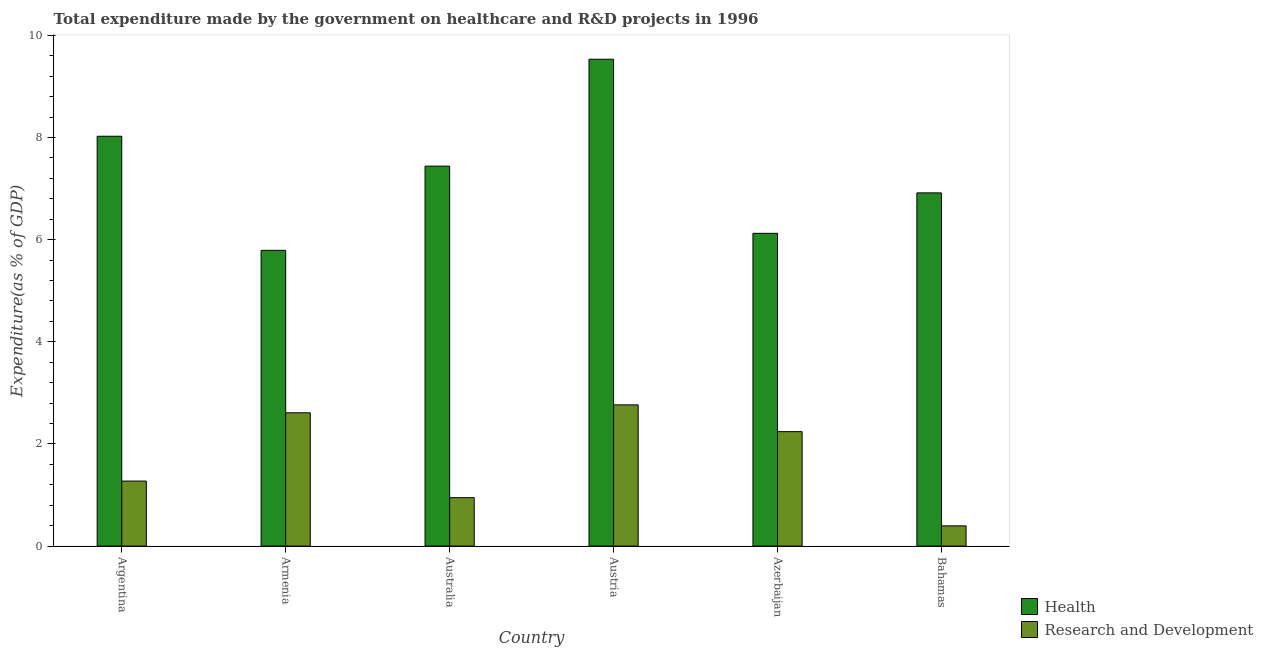How many different coloured bars are there?
Your answer should be very brief. 2. Are the number of bars per tick equal to the number of legend labels?
Provide a short and direct response. Yes. Are the number of bars on each tick of the X-axis equal?
Your answer should be compact. Yes. What is the label of the 2nd group of bars from the left?
Offer a terse response. Armenia. What is the expenditure in r&d in Argentina?
Provide a succinct answer. 1.27. Across all countries, what is the maximum expenditure in healthcare?
Give a very brief answer. 9.53. Across all countries, what is the minimum expenditure in healthcare?
Provide a succinct answer. 5.79. In which country was the expenditure in r&d minimum?
Give a very brief answer. Bahamas. What is the total expenditure in healthcare in the graph?
Provide a succinct answer. 43.83. What is the difference between the expenditure in r&d in Austria and that in Azerbaijan?
Give a very brief answer. 0.52. What is the difference between the expenditure in r&d in Bahamas and the expenditure in healthcare in Azerbaijan?
Keep it short and to the point. -5.73. What is the average expenditure in healthcare per country?
Make the answer very short. 7.3. What is the difference between the expenditure in r&d and expenditure in healthcare in Azerbaijan?
Give a very brief answer. -3.88. In how many countries, is the expenditure in healthcare greater than 8 %?
Your answer should be compact. 2. What is the ratio of the expenditure in r&d in Argentina to that in Azerbaijan?
Provide a succinct answer. 0.57. Is the expenditure in r&d in Argentina less than that in Austria?
Give a very brief answer. Yes. Is the difference between the expenditure in r&d in Armenia and Azerbaijan greater than the difference between the expenditure in healthcare in Armenia and Azerbaijan?
Provide a short and direct response. Yes. What is the difference between the highest and the second highest expenditure in healthcare?
Give a very brief answer. 1.51. What is the difference between the highest and the lowest expenditure in r&d?
Keep it short and to the point. 2.37. Is the sum of the expenditure in healthcare in Argentina and Armenia greater than the maximum expenditure in r&d across all countries?
Your answer should be compact. Yes. What does the 2nd bar from the left in Bahamas represents?
Keep it short and to the point. Research and Development. What does the 2nd bar from the right in Australia represents?
Give a very brief answer. Health. How many bars are there?
Your answer should be compact. 12. How many countries are there in the graph?
Make the answer very short. 6. What is the difference between two consecutive major ticks on the Y-axis?
Ensure brevity in your answer.  2. Are the values on the major ticks of Y-axis written in scientific E-notation?
Your answer should be very brief. No. Where does the legend appear in the graph?
Give a very brief answer. Bottom right. What is the title of the graph?
Your answer should be compact. Total expenditure made by the government on healthcare and R&D projects in 1996. Does "Technicians" appear as one of the legend labels in the graph?
Give a very brief answer. No. What is the label or title of the X-axis?
Your answer should be compact. Country. What is the label or title of the Y-axis?
Ensure brevity in your answer.  Expenditure(as % of GDP). What is the Expenditure(as % of GDP) in Health in Argentina?
Keep it short and to the point. 8.02. What is the Expenditure(as % of GDP) in Research and Development in Argentina?
Give a very brief answer. 1.27. What is the Expenditure(as % of GDP) of Health in Armenia?
Offer a terse response. 5.79. What is the Expenditure(as % of GDP) in Research and Development in Armenia?
Your response must be concise. 2.61. What is the Expenditure(as % of GDP) of Health in Australia?
Keep it short and to the point. 7.44. What is the Expenditure(as % of GDP) in Research and Development in Australia?
Offer a very short reply. 0.95. What is the Expenditure(as % of GDP) in Health in Austria?
Ensure brevity in your answer.  9.53. What is the Expenditure(as % of GDP) in Research and Development in Austria?
Your answer should be very brief. 2.77. What is the Expenditure(as % of GDP) of Health in Azerbaijan?
Make the answer very short. 6.12. What is the Expenditure(as % of GDP) of Research and Development in Azerbaijan?
Your answer should be very brief. 2.24. What is the Expenditure(as % of GDP) in Health in Bahamas?
Your answer should be very brief. 6.92. What is the Expenditure(as % of GDP) of Research and Development in Bahamas?
Keep it short and to the point. 0.4. Across all countries, what is the maximum Expenditure(as % of GDP) of Health?
Your answer should be very brief. 9.53. Across all countries, what is the maximum Expenditure(as % of GDP) in Research and Development?
Make the answer very short. 2.77. Across all countries, what is the minimum Expenditure(as % of GDP) in Health?
Provide a short and direct response. 5.79. Across all countries, what is the minimum Expenditure(as % of GDP) of Research and Development?
Give a very brief answer. 0.4. What is the total Expenditure(as % of GDP) in Health in the graph?
Your response must be concise. 43.83. What is the total Expenditure(as % of GDP) of Research and Development in the graph?
Your answer should be very brief. 10.23. What is the difference between the Expenditure(as % of GDP) of Health in Argentina and that in Armenia?
Offer a very short reply. 2.23. What is the difference between the Expenditure(as % of GDP) in Research and Development in Argentina and that in Armenia?
Provide a succinct answer. -1.34. What is the difference between the Expenditure(as % of GDP) in Health in Argentina and that in Australia?
Give a very brief answer. 0.59. What is the difference between the Expenditure(as % of GDP) in Research and Development in Argentina and that in Australia?
Give a very brief answer. 0.33. What is the difference between the Expenditure(as % of GDP) in Health in Argentina and that in Austria?
Offer a terse response. -1.51. What is the difference between the Expenditure(as % of GDP) in Research and Development in Argentina and that in Austria?
Provide a short and direct response. -1.49. What is the difference between the Expenditure(as % of GDP) of Health in Argentina and that in Azerbaijan?
Make the answer very short. 1.9. What is the difference between the Expenditure(as % of GDP) of Research and Development in Argentina and that in Azerbaijan?
Your answer should be compact. -0.97. What is the difference between the Expenditure(as % of GDP) of Health in Argentina and that in Bahamas?
Make the answer very short. 1.11. What is the difference between the Expenditure(as % of GDP) in Research and Development in Argentina and that in Bahamas?
Keep it short and to the point. 0.88. What is the difference between the Expenditure(as % of GDP) of Health in Armenia and that in Australia?
Provide a succinct answer. -1.65. What is the difference between the Expenditure(as % of GDP) of Research and Development in Armenia and that in Australia?
Offer a terse response. 1.66. What is the difference between the Expenditure(as % of GDP) of Health in Armenia and that in Austria?
Your answer should be compact. -3.74. What is the difference between the Expenditure(as % of GDP) of Research and Development in Armenia and that in Austria?
Offer a terse response. -0.15. What is the difference between the Expenditure(as % of GDP) in Health in Armenia and that in Azerbaijan?
Provide a succinct answer. -0.33. What is the difference between the Expenditure(as % of GDP) of Research and Development in Armenia and that in Azerbaijan?
Offer a terse response. 0.37. What is the difference between the Expenditure(as % of GDP) of Health in Armenia and that in Bahamas?
Provide a succinct answer. -1.13. What is the difference between the Expenditure(as % of GDP) of Research and Development in Armenia and that in Bahamas?
Give a very brief answer. 2.21. What is the difference between the Expenditure(as % of GDP) of Health in Australia and that in Austria?
Ensure brevity in your answer.  -2.09. What is the difference between the Expenditure(as % of GDP) in Research and Development in Australia and that in Austria?
Give a very brief answer. -1.82. What is the difference between the Expenditure(as % of GDP) in Health in Australia and that in Azerbaijan?
Offer a very short reply. 1.32. What is the difference between the Expenditure(as % of GDP) of Research and Development in Australia and that in Azerbaijan?
Provide a succinct answer. -1.29. What is the difference between the Expenditure(as % of GDP) of Health in Australia and that in Bahamas?
Keep it short and to the point. 0.52. What is the difference between the Expenditure(as % of GDP) in Research and Development in Australia and that in Bahamas?
Keep it short and to the point. 0.55. What is the difference between the Expenditure(as % of GDP) of Health in Austria and that in Azerbaijan?
Your answer should be very brief. 3.41. What is the difference between the Expenditure(as % of GDP) of Research and Development in Austria and that in Azerbaijan?
Give a very brief answer. 0.52. What is the difference between the Expenditure(as % of GDP) of Health in Austria and that in Bahamas?
Provide a succinct answer. 2.62. What is the difference between the Expenditure(as % of GDP) in Research and Development in Austria and that in Bahamas?
Provide a short and direct response. 2.37. What is the difference between the Expenditure(as % of GDP) of Health in Azerbaijan and that in Bahamas?
Provide a succinct answer. -0.79. What is the difference between the Expenditure(as % of GDP) in Research and Development in Azerbaijan and that in Bahamas?
Provide a short and direct response. 1.84. What is the difference between the Expenditure(as % of GDP) of Health in Argentina and the Expenditure(as % of GDP) of Research and Development in Armenia?
Your answer should be compact. 5.41. What is the difference between the Expenditure(as % of GDP) in Health in Argentina and the Expenditure(as % of GDP) in Research and Development in Australia?
Provide a succinct answer. 7.08. What is the difference between the Expenditure(as % of GDP) in Health in Argentina and the Expenditure(as % of GDP) in Research and Development in Austria?
Your answer should be very brief. 5.26. What is the difference between the Expenditure(as % of GDP) in Health in Argentina and the Expenditure(as % of GDP) in Research and Development in Azerbaijan?
Ensure brevity in your answer.  5.78. What is the difference between the Expenditure(as % of GDP) in Health in Argentina and the Expenditure(as % of GDP) in Research and Development in Bahamas?
Offer a terse response. 7.63. What is the difference between the Expenditure(as % of GDP) in Health in Armenia and the Expenditure(as % of GDP) in Research and Development in Australia?
Give a very brief answer. 4.84. What is the difference between the Expenditure(as % of GDP) in Health in Armenia and the Expenditure(as % of GDP) in Research and Development in Austria?
Make the answer very short. 3.03. What is the difference between the Expenditure(as % of GDP) of Health in Armenia and the Expenditure(as % of GDP) of Research and Development in Azerbaijan?
Your answer should be compact. 3.55. What is the difference between the Expenditure(as % of GDP) in Health in Armenia and the Expenditure(as % of GDP) in Research and Development in Bahamas?
Give a very brief answer. 5.39. What is the difference between the Expenditure(as % of GDP) in Health in Australia and the Expenditure(as % of GDP) in Research and Development in Austria?
Give a very brief answer. 4.67. What is the difference between the Expenditure(as % of GDP) in Health in Australia and the Expenditure(as % of GDP) in Research and Development in Azerbaijan?
Give a very brief answer. 5.2. What is the difference between the Expenditure(as % of GDP) of Health in Australia and the Expenditure(as % of GDP) of Research and Development in Bahamas?
Ensure brevity in your answer.  7.04. What is the difference between the Expenditure(as % of GDP) in Health in Austria and the Expenditure(as % of GDP) in Research and Development in Azerbaijan?
Offer a terse response. 7.29. What is the difference between the Expenditure(as % of GDP) of Health in Austria and the Expenditure(as % of GDP) of Research and Development in Bahamas?
Offer a terse response. 9.14. What is the difference between the Expenditure(as % of GDP) in Health in Azerbaijan and the Expenditure(as % of GDP) in Research and Development in Bahamas?
Offer a very short reply. 5.73. What is the average Expenditure(as % of GDP) in Health per country?
Keep it short and to the point. 7.3. What is the average Expenditure(as % of GDP) in Research and Development per country?
Your answer should be compact. 1.71. What is the difference between the Expenditure(as % of GDP) in Health and Expenditure(as % of GDP) in Research and Development in Argentina?
Keep it short and to the point. 6.75. What is the difference between the Expenditure(as % of GDP) of Health and Expenditure(as % of GDP) of Research and Development in Armenia?
Provide a succinct answer. 3.18. What is the difference between the Expenditure(as % of GDP) in Health and Expenditure(as % of GDP) in Research and Development in Australia?
Keep it short and to the point. 6.49. What is the difference between the Expenditure(as % of GDP) in Health and Expenditure(as % of GDP) in Research and Development in Austria?
Provide a succinct answer. 6.77. What is the difference between the Expenditure(as % of GDP) of Health and Expenditure(as % of GDP) of Research and Development in Azerbaijan?
Provide a succinct answer. 3.88. What is the difference between the Expenditure(as % of GDP) in Health and Expenditure(as % of GDP) in Research and Development in Bahamas?
Ensure brevity in your answer.  6.52. What is the ratio of the Expenditure(as % of GDP) in Health in Argentina to that in Armenia?
Offer a terse response. 1.39. What is the ratio of the Expenditure(as % of GDP) of Research and Development in Argentina to that in Armenia?
Offer a terse response. 0.49. What is the ratio of the Expenditure(as % of GDP) of Health in Argentina to that in Australia?
Ensure brevity in your answer.  1.08. What is the ratio of the Expenditure(as % of GDP) in Research and Development in Argentina to that in Australia?
Keep it short and to the point. 1.34. What is the ratio of the Expenditure(as % of GDP) in Health in Argentina to that in Austria?
Make the answer very short. 0.84. What is the ratio of the Expenditure(as % of GDP) of Research and Development in Argentina to that in Austria?
Provide a succinct answer. 0.46. What is the ratio of the Expenditure(as % of GDP) in Health in Argentina to that in Azerbaijan?
Offer a terse response. 1.31. What is the ratio of the Expenditure(as % of GDP) in Research and Development in Argentina to that in Azerbaijan?
Your answer should be compact. 0.57. What is the ratio of the Expenditure(as % of GDP) of Health in Argentina to that in Bahamas?
Your response must be concise. 1.16. What is the ratio of the Expenditure(as % of GDP) in Research and Development in Argentina to that in Bahamas?
Keep it short and to the point. 3.21. What is the ratio of the Expenditure(as % of GDP) in Health in Armenia to that in Australia?
Provide a short and direct response. 0.78. What is the ratio of the Expenditure(as % of GDP) in Research and Development in Armenia to that in Australia?
Give a very brief answer. 2.75. What is the ratio of the Expenditure(as % of GDP) of Health in Armenia to that in Austria?
Keep it short and to the point. 0.61. What is the ratio of the Expenditure(as % of GDP) in Research and Development in Armenia to that in Austria?
Make the answer very short. 0.94. What is the ratio of the Expenditure(as % of GDP) in Health in Armenia to that in Azerbaijan?
Your response must be concise. 0.95. What is the ratio of the Expenditure(as % of GDP) in Research and Development in Armenia to that in Azerbaijan?
Your response must be concise. 1.16. What is the ratio of the Expenditure(as % of GDP) of Health in Armenia to that in Bahamas?
Provide a short and direct response. 0.84. What is the ratio of the Expenditure(as % of GDP) of Research and Development in Armenia to that in Bahamas?
Ensure brevity in your answer.  6.59. What is the ratio of the Expenditure(as % of GDP) in Health in Australia to that in Austria?
Provide a short and direct response. 0.78. What is the ratio of the Expenditure(as % of GDP) in Research and Development in Australia to that in Austria?
Keep it short and to the point. 0.34. What is the ratio of the Expenditure(as % of GDP) in Health in Australia to that in Azerbaijan?
Give a very brief answer. 1.21. What is the ratio of the Expenditure(as % of GDP) of Research and Development in Australia to that in Azerbaijan?
Make the answer very short. 0.42. What is the ratio of the Expenditure(as % of GDP) in Health in Australia to that in Bahamas?
Keep it short and to the point. 1.08. What is the ratio of the Expenditure(as % of GDP) of Research and Development in Australia to that in Bahamas?
Offer a very short reply. 2.39. What is the ratio of the Expenditure(as % of GDP) in Health in Austria to that in Azerbaijan?
Your response must be concise. 1.56. What is the ratio of the Expenditure(as % of GDP) of Research and Development in Austria to that in Azerbaijan?
Give a very brief answer. 1.23. What is the ratio of the Expenditure(as % of GDP) of Health in Austria to that in Bahamas?
Give a very brief answer. 1.38. What is the ratio of the Expenditure(as % of GDP) in Research and Development in Austria to that in Bahamas?
Give a very brief answer. 6.98. What is the ratio of the Expenditure(as % of GDP) of Health in Azerbaijan to that in Bahamas?
Make the answer very short. 0.89. What is the ratio of the Expenditure(as % of GDP) of Research and Development in Azerbaijan to that in Bahamas?
Make the answer very short. 5.66. What is the difference between the highest and the second highest Expenditure(as % of GDP) in Health?
Your answer should be very brief. 1.51. What is the difference between the highest and the second highest Expenditure(as % of GDP) of Research and Development?
Your response must be concise. 0.15. What is the difference between the highest and the lowest Expenditure(as % of GDP) of Health?
Your answer should be compact. 3.74. What is the difference between the highest and the lowest Expenditure(as % of GDP) in Research and Development?
Your response must be concise. 2.37. 